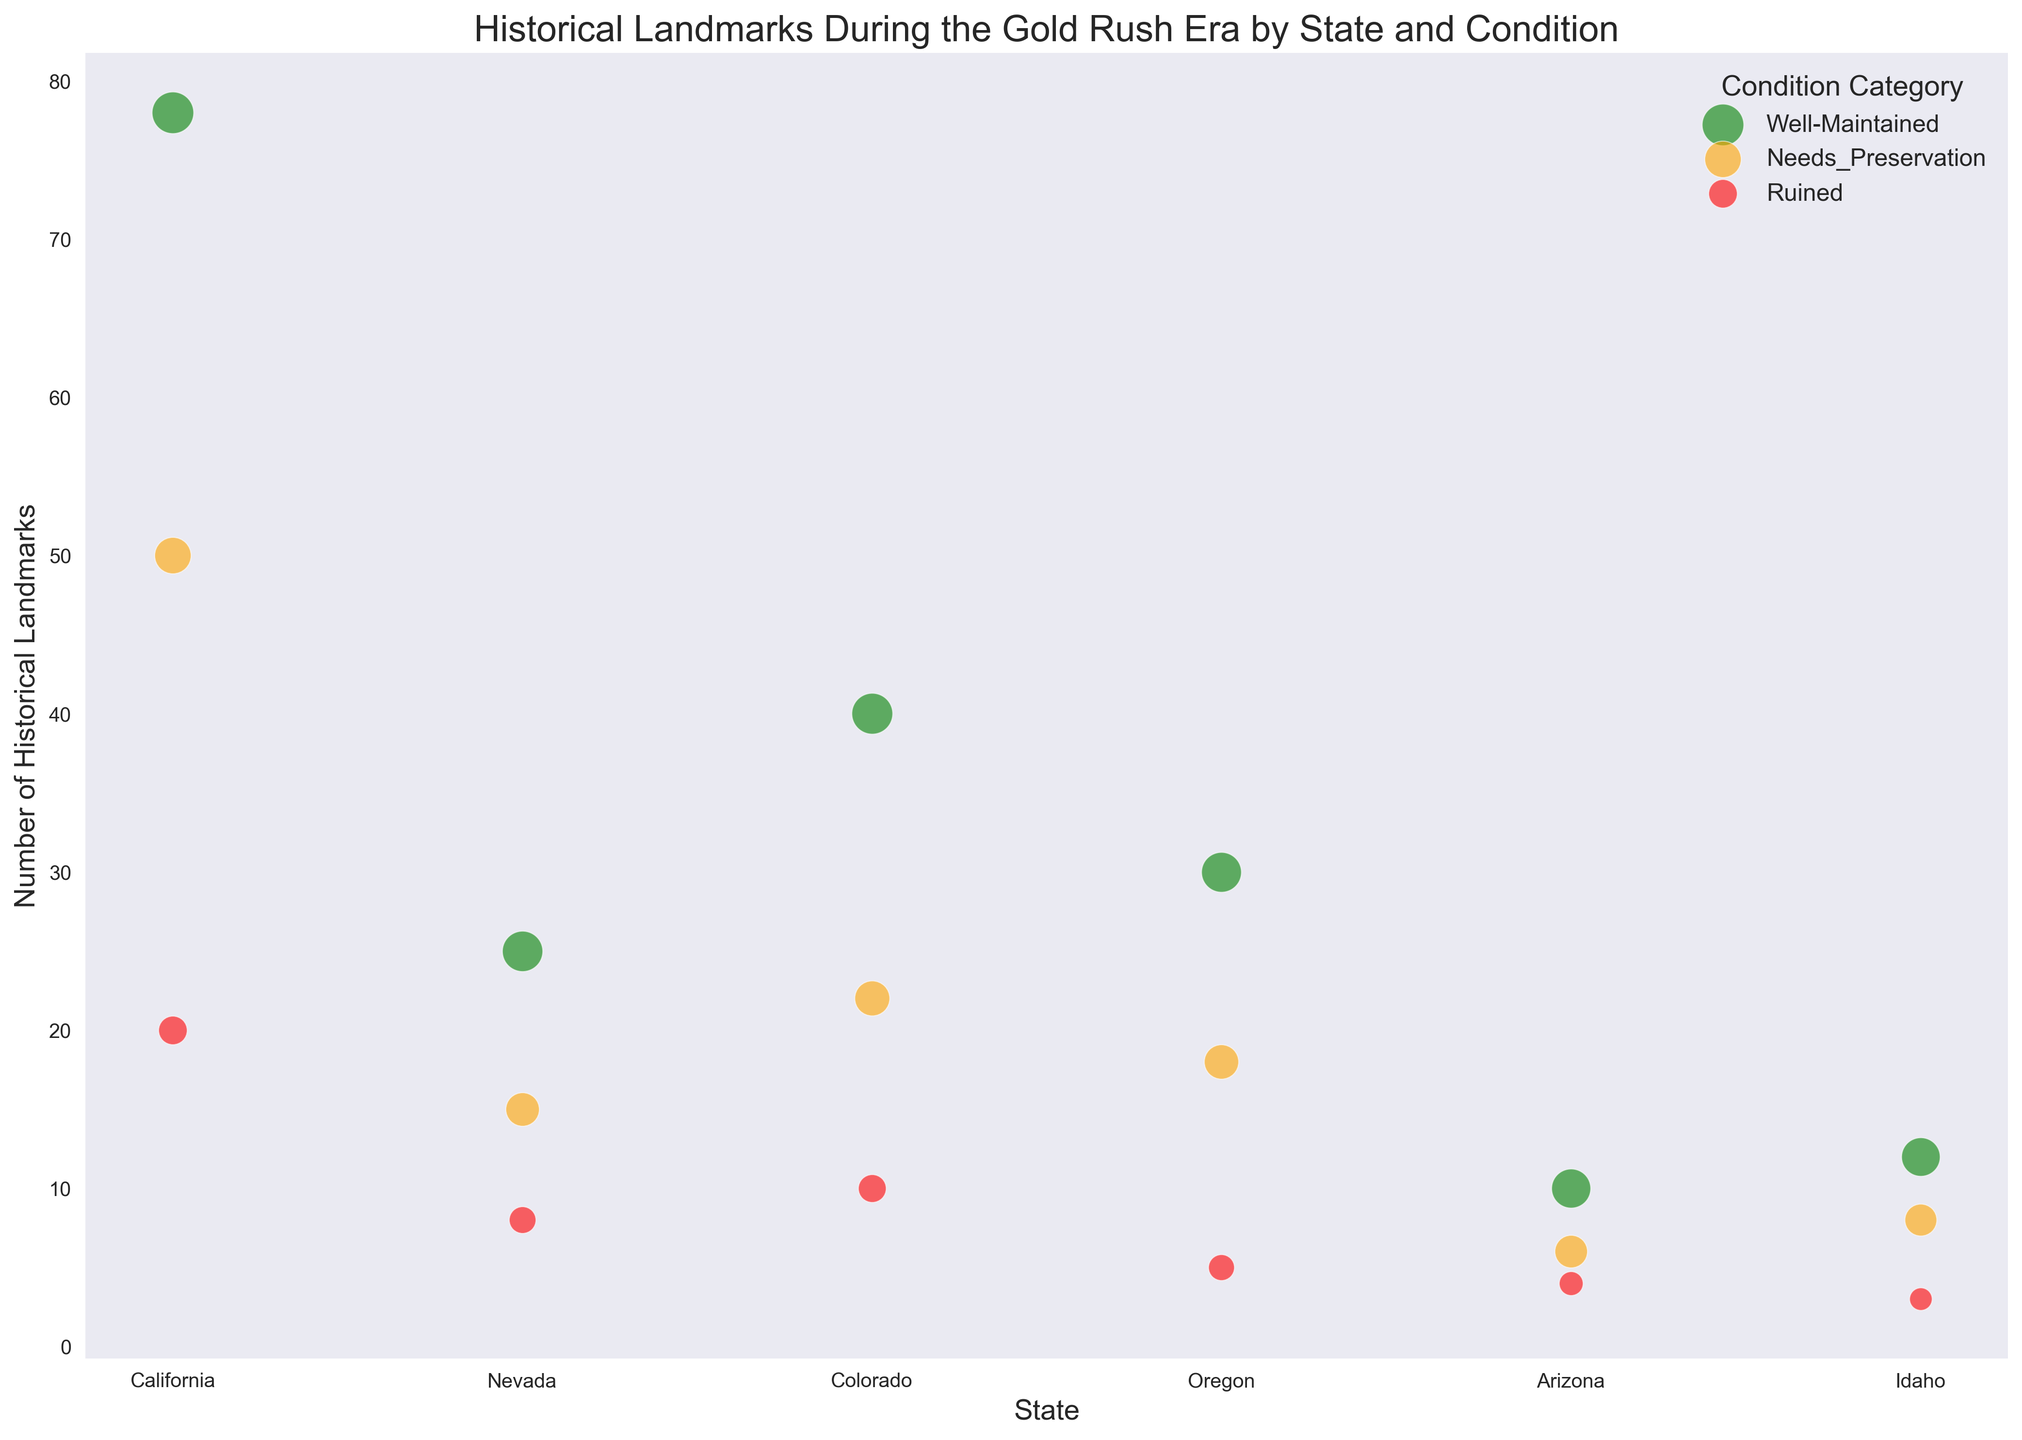What is the total number of historical landmarks in California? There are three categories for California: Well-Maintained (78), Needs Preservation (50), and Ruined (20). Summing these up gives 78 + 50 + 20 = 148.
Answer: 148 Which state has the largest number of Well-Maintained historical landmarks? By comparing the Well-Maintained landmarks in each state, we find California has 78, Nevada has 25, Colorado has 40, Oregon has 30, Arizona has 10, and Idaho has 12. The largest number is 78 in California.
Answer: California How does the number of Ruined historical landmarks in Nevada compare to those in Arizona? Nevada has 8 Ruined landmarks, while Arizona has 4. 8 is greater than 4, indicating Nevada has more Ruined landmarks than Arizona.
Answer: Nevada What is the difference in the total number of historical landmarks between Colorado and Oregon? Colorado has a total of 40 + 22 + 10 = 72 landmarks, and Oregon has 30 + 18 + 5 = 53 landmarks. The difference is 72 - 53 = 19.
Answer: 19 Which category has the highest average Condition Score across all states? Calculate the average Condition Score for each category: 
1. Well-Maintained: (85 + 80 + 82 + 78 + 75 + 73) / 6 = 78.83
2. Needs Preservation: (65 + 55 + 60 + 58 + 52 + 50) / 6 = 56.67
3. Ruined: (40 + 35 + 38 + 33 + 28 + 25) / 6 = 33.17
Well-Maintained has the highest average Condition Score.
Answer: Well-Maintained What is the total number of historical landmarks that need preservation across all states? Summing the Needs Preservation landmarks in each state gives 50 (California) + 15 (Nevada) + 22 (Colorado) + 18 (Oregon) + 6 (Arizona) + 8 (Idaho) = 119.
Answer: 119 In which state is the bubble size largest for the Well-Maintained category, and what does this indicate? The bubble size is determined by the Condition Score. Calculate the size (Condition Score * 5) for Well-Maintained landmarks for each state:
1. California: 85 * 5 = 425
2. Nevada: 80 * 5 = 400
3. Colorado: 82 * 5 = 410
4. Oregon: 78 * 5 = 390
5. Arizona: 75 * 5 = 375
6. Idaho: 73 * 5 = 365
The largest is 425 for California, indicating it has the best average condition score.
Answer: California Which state has the highest overall average Condition Score, considering all categories? Calculate the total Condition Score and divide by the total number of landmarks for each state:
1. California: (85*78 + 65*50 + 40*20) / 148 = 70.95
2. Nevada: (80*25 + 55*15 + 35*8) / 48 = 63.75
3. Colorado: (82*40 + 60*22 + 38*10) / 72 = 68.81
4. Oregon: (78*30 + 58*18 + 33*5) / 53 = 62.74
5. Arizona: (75*10 + 52*6 + 28*4) / 20 = 56.10
6. Idaho: (73*12 + 50*8 + 25*3) / 23 = 56.57
California has the highest average Condition Score of 70.95.
Answer: California 